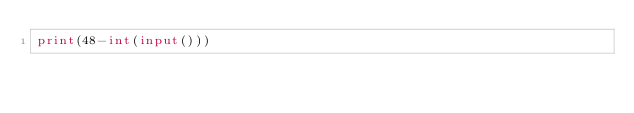Convert code to text. <code><loc_0><loc_0><loc_500><loc_500><_Python_>print(48-int(input()))</code> 